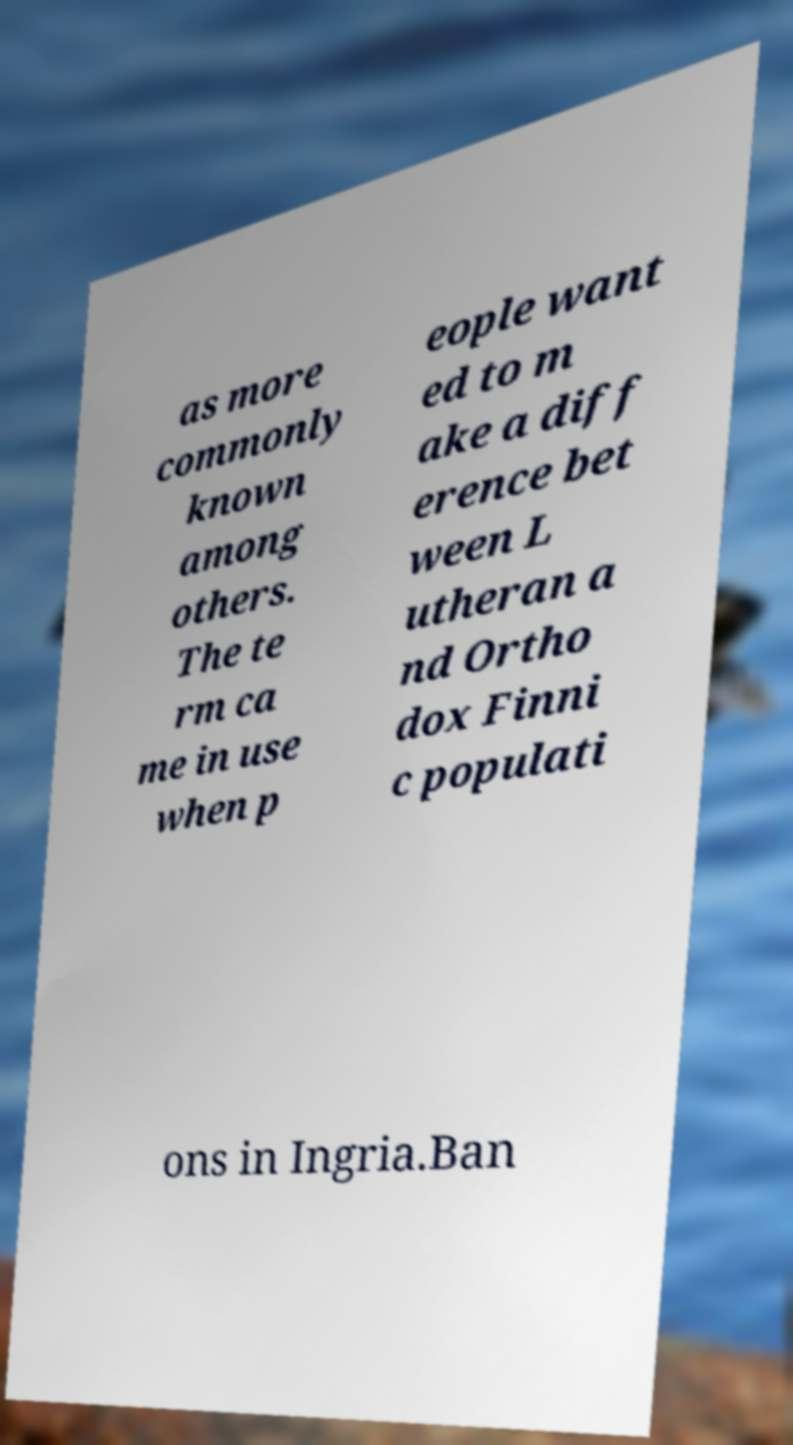Please identify and transcribe the text found in this image. as more commonly known among others. The te rm ca me in use when p eople want ed to m ake a diff erence bet ween L utheran a nd Ortho dox Finni c populati ons in Ingria.Ban 